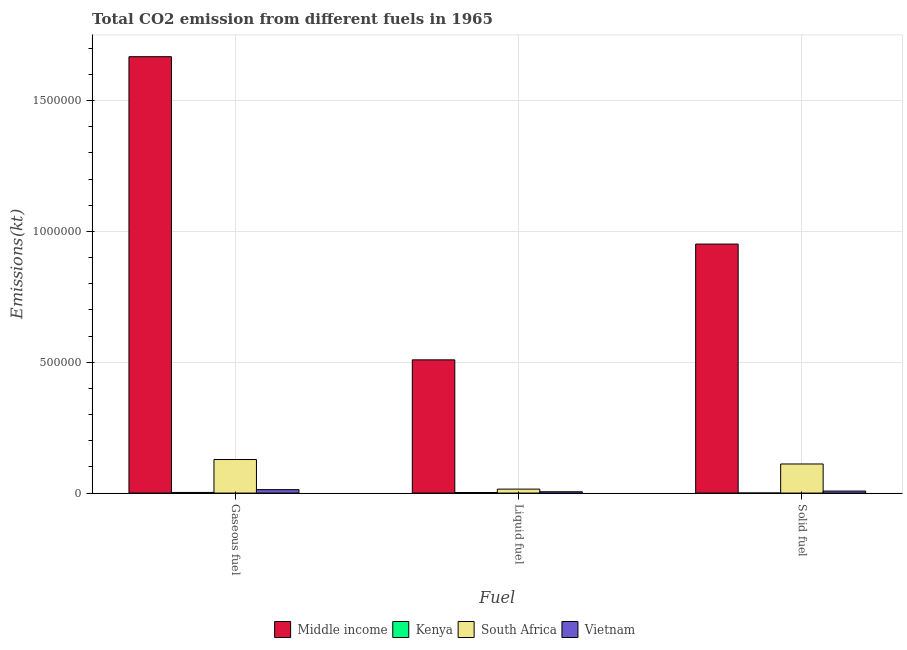How many different coloured bars are there?
Provide a succinct answer. 4. How many groups of bars are there?
Your response must be concise. 3. How many bars are there on the 2nd tick from the left?
Your answer should be compact. 4. How many bars are there on the 3rd tick from the right?
Provide a short and direct response. 4. What is the label of the 2nd group of bars from the left?
Your answer should be compact. Liquid fuel. What is the amount of co2 emissions from gaseous fuel in Middle income?
Provide a short and direct response. 1.67e+06. Across all countries, what is the maximum amount of co2 emissions from gaseous fuel?
Your answer should be very brief. 1.67e+06. Across all countries, what is the minimum amount of co2 emissions from solid fuel?
Ensure brevity in your answer.  146.68. In which country was the amount of co2 emissions from gaseous fuel minimum?
Your answer should be very brief. Kenya. What is the total amount of co2 emissions from gaseous fuel in the graph?
Give a very brief answer. 1.81e+06. What is the difference between the amount of co2 emissions from solid fuel in South Africa and that in Kenya?
Make the answer very short. 1.11e+05. What is the difference between the amount of co2 emissions from gaseous fuel in South Africa and the amount of co2 emissions from solid fuel in Kenya?
Provide a succinct answer. 1.28e+05. What is the average amount of co2 emissions from solid fuel per country?
Ensure brevity in your answer.  2.68e+05. What is the difference between the amount of co2 emissions from gaseous fuel and amount of co2 emissions from solid fuel in Kenya?
Offer a very short reply. 2321.21. What is the ratio of the amount of co2 emissions from liquid fuel in South Africa to that in Kenya?
Ensure brevity in your answer.  7.27. What is the difference between the highest and the second highest amount of co2 emissions from gaseous fuel?
Your response must be concise. 1.54e+06. What is the difference between the highest and the lowest amount of co2 emissions from solid fuel?
Provide a succinct answer. 9.52e+05. In how many countries, is the amount of co2 emissions from gaseous fuel greater than the average amount of co2 emissions from gaseous fuel taken over all countries?
Keep it short and to the point. 1. Is the sum of the amount of co2 emissions from solid fuel in Vietnam and Middle income greater than the maximum amount of co2 emissions from gaseous fuel across all countries?
Provide a short and direct response. No. What does the 3rd bar from the left in Gaseous fuel represents?
Offer a terse response. South Africa. What does the 3rd bar from the right in Liquid fuel represents?
Provide a short and direct response. Kenya. Is it the case that in every country, the sum of the amount of co2 emissions from gaseous fuel and amount of co2 emissions from liquid fuel is greater than the amount of co2 emissions from solid fuel?
Give a very brief answer. Yes. How many bars are there?
Give a very brief answer. 12. How many countries are there in the graph?
Your answer should be very brief. 4. What is the difference between two consecutive major ticks on the Y-axis?
Provide a short and direct response. 5.00e+05. Does the graph contain any zero values?
Ensure brevity in your answer.  No. Does the graph contain grids?
Keep it short and to the point. Yes. Where does the legend appear in the graph?
Your response must be concise. Bottom center. How are the legend labels stacked?
Your answer should be very brief. Horizontal. What is the title of the graph?
Keep it short and to the point. Total CO2 emission from different fuels in 1965. Does "Heavily indebted poor countries" appear as one of the legend labels in the graph?
Make the answer very short. No. What is the label or title of the X-axis?
Provide a short and direct response. Fuel. What is the label or title of the Y-axis?
Your response must be concise. Emissions(kt). What is the Emissions(kt) in Middle income in Gaseous fuel?
Your answer should be very brief. 1.67e+06. What is the Emissions(kt) of Kenya in Gaseous fuel?
Your answer should be compact. 2467.89. What is the Emissions(kt) in South Africa in Gaseous fuel?
Provide a succinct answer. 1.28e+05. What is the Emissions(kt) of Vietnam in Gaseous fuel?
Make the answer very short. 1.32e+04. What is the Emissions(kt) of Middle income in Liquid fuel?
Your response must be concise. 5.09e+05. What is the Emissions(kt) of Kenya in Liquid fuel?
Make the answer very short. 2082.86. What is the Emissions(kt) of South Africa in Liquid fuel?
Offer a terse response. 1.51e+04. What is the Emissions(kt) of Vietnam in Liquid fuel?
Offer a very short reply. 4998.12. What is the Emissions(kt) of Middle income in Solid fuel?
Offer a terse response. 9.52e+05. What is the Emissions(kt) of Kenya in Solid fuel?
Give a very brief answer. 146.68. What is the Emissions(kt) in South Africa in Solid fuel?
Your answer should be very brief. 1.11e+05. What is the Emissions(kt) in Vietnam in Solid fuel?
Offer a terse response. 7693.37. Across all Fuel, what is the maximum Emissions(kt) in Middle income?
Ensure brevity in your answer.  1.67e+06. Across all Fuel, what is the maximum Emissions(kt) in Kenya?
Offer a terse response. 2467.89. Across all Fuel, what is the maximum Emissions(kt) in South Africa?
Your response must be concise. 1.28e+05. Across all Fuel, what is the maximum Emissions(kt) of Vietnam?
Keep it short and to the point. 1.32e+04. Across all Fuel, what is the minimum Emissions(kt) of Middle income?
Your answer should be compact. 5.09e+05. Across all Fuel, what is the minimum Emissions(kt) of Kenya?
Keep it short and to the point. 146.68. Across all Fuel, what is the minimum Emissions(kt) of South Africa?
Offer a very short reply. 1.51e+04. Across all Fuel, what is the minimum Emissions(kt) of Vietnam?
Give a very brief answer. 4998.12. What is the total Emissions(kt) in Middle income in the graph?
Provide a succinct answer. 3.13e+06. What is the total Emissions(kt) in Kenya in the graph?
Keep it short and to the point. 4697.43. What is the total Emissions(kt) of South Africa in the graph?
Ensure brevity in your answer.  2.55e+05. What is the total Emissions(kt) in Vietnam in the graph?
Give a very brief answer. 2.59e+04. What is the difference between the Emissions(kt) of Middle income in Gaseous fuel and that in Liquid fuel?
Ensure brevity in your answer.  1.16e+06. What is the difference between the Emissions(kt) of Kenya in Gaseous fuel and that in Liquid fuel?
Your answer should be compact. 385.04. What is the difference between the Emissions(kt) in South Africa in Gaseous fuel and that in Liquid fuel?
Make the answer very short. 1.13e+05. What is the difference between the Emissions(kt) of Vietnam in Gaseous fuel and that in Liquid fuel?
Your response must be concise. 8166.41. What is the difference between the Emissions(kt) of Middle income in Gaseous fuel and that in Solid fuel?
Ensure brevity in your answer.  7.16e+05. What is the difference between the Emissions(kt) in Kenya in Gaseous fuel and that in Solid fuel?
Give a very brief answer. 2321.21. What is the difference between the Emissions(kt) in South Africa in Gaseous fuel and that in Solid fuel?
Ensure brevity in your answer.  1.71e+04. What is the difference between the Emissions(kt) of Vietnam in Gaseous fuel and that in Solid fuel?
Your answer should be compact. 5471.16. What is the difference between the Emissions(kt) in Middle income in Liquid fuel and that in Solid fuel?
Make the answer very short. -4.43e+05. What is the difference between the Emissions(kt) of Kenya in Liquid fuel and that in Solid fuel?
Provide a succinct answer. 1936.18. What is the difference between the Emissions(kt) of South Africa in Liquid fuel and that in Solid fuel?
Ensure brevity in your answer.  -9.61e+04. What is the difference between the Emissions(kt) in Vietnam in Liquid fuel and that in Solid fuel?
Your answer should be very brief. -2695.24. What is the difference between the Emissions(kt) in Middle income in Gaseous fuel and the Emissions(kt) in Kenya in Liquid fuel?
Ensure brevity in your answer.  1.67e+06. What is the difference between the Emissions(kt) of Middle income in Gaseous fuel and the Emissions(kt) of South Africa in Liquid fuel?
Keep it short and to the point. 1.65e+06. What is the difference between the Emissions(kt) of Middle income in Gaseous fuel and the Emissions(kt) of Vietnam in Liquid fuel?
Offer a terse response. 1.66e+06. What is the difference between the Emissions(kt) of Kenya in Gaseous fuel and the Emissions(kt) of South Africa in Liquid fuel?
Offer a very short reply. -1.27e+04. What is the difference between the Emissions(kt) of Kenya in Gaseous fuel and the Emissions(kt) of Vietnam in Liquid fuel?
Provide a succinct answer. -2530.23. What is the difference between the Emissions(kt) in South Africa in Gaseous fuel and the Emissions(kt) in Vietnam in Liquid fuel?
Offer a terse response. 1.23e+05. What is the difference between the Emissions(kt) in Middle income in Gaseous fuel and the Emissions(kt) in Kenya in Solid fuel?
Offer a terse response. 1.67e+06. What is the difference between the Emissions(kt) of Middle income in Gaseous fuel and the Emissions(kt) of South Africa in Solid fuel?
Give a very brief answer. 1.56e+06. What is the difference between the Emissions(kt) of Middle income in Gaseous fuel and the Emissions(kt) of Vietnam in Solid fuel?
Your response must be concise. 1.66e+06. What is the difference between the Emissions(kt) of Kenya in Gaseous fuel and the Emissions(kt) of South Africa in Solid fuel?
Offer a very short reply. -1.09e+05. What is the difference between the Emissions(kt) in Kenya in Gaseous fuel and the Emissions(kt) in Vietnam in Solid fuel?
Ensure brevity in your answer.  -5225.48. What is the difference between the Emissions(kt) in South Africa in Gaseous fuel and the Emissions(kt) in Vietnam in Solid fuel?
Your response must be concise. 1.21e+05. What is the difference between the Emissions(kt) of Middle income in Liquid fuel and the Emissions(kt) of Kenya in Solid fuel?
Ensure brevity in your answer.  5.09e+05. What is the difference between the Emissions(kt) in Middle income in Liquid fuel and the Emissions(kt) in South Africa in Solid fuel?
Make the answer very short. 3.98e+05. What is the difference between the Emissions(kt) of Middle income in Liquid fuel and the Emissions(kt) of Vietnam in Solid fuel?
Keep it short and to the point. 5.02e+05. What is the difference between the Emissions(kt) of Kenya in Liquid fuel and the Emissions(kt) of South Africa in Solid fuel?
Provide a short and direct response. -1.09e+05. What is the difference between the Emissions(kt) of Kenya in Liquid fuel and the Emissions(kt) of Vietnam in Solid fuel?
Keep it short and to the point. -5610.51. What is the difference between the Emissions(kt) in South Africa in Liquid fuel and the Emissions(kt) in Vietnam in Solid fuel?
Your answer should be compact. 7440.34. What is the average Emissions(kt) of Middle income per Fuel?
Ensure brevity in your answer.  1.04e+06. What is the average Emissions(kt) in Kenya per Fuel?
Your answer should be very brief. 1565.81. What is the average Emissions(kt) in South Africa per Fuel?
Your response must be concise. 8.49e+04. What is the average Emissions(kt) in Vietnam per Fuel?
Your answer should be compact. 8618.67. What is the difference between the Emissions(kt) of Middle income and Emissions(kt) of Kenya in Gaseous fuel?
Offer a terse response. 1.67e+06. What is the difference between the Emissions(kt) in Middle income and Emissions(kt) in South Africa in Gaseous fuel?
Offer a very short reply. 1.54e+06. What is the difference between the Emissions(kt) of Middle income and Emissions(kt) of Vietnam in Gaseous fuel?
Provide a short and direct response. 1.65e+06. What is the difference between the Emissions(kt) in Kenya and Emissions(kt) in South Africa in Gaseous fuel?
Provide a succinct answer. -1.26e+05. What is the difference between the Emissions(kt) of Kenya and Emissions(kt) of Vietnam in Gaseous fuel?
Offer a very short reply. -1.07e+04. What is the difference between the Emissions(kt) of South Africa and Emissions(kt) of Vietnam in Gaseous fuel?
Make the answer very short. 1.15e+05. What is the difference between the Emissions(kt) in Middle income and Emissions(kt) in Kenya in Liquid fuel?
Offer a very short reply. 5.07e+05. What is the difference between the Emissions(kt) in Middle income and Emissions(kt) in South Africa in Liquid fuel?
Offer a very short reply. 4.94e+05. What is the difference between the Emissions(kt) of Middle income and Emissions(kt) of Vietnam in Liquid fuel?
Your answer should be compact. 5.04e+05. What is the difference between the Emissions(kt) in Kenya and Emissions(kt) in South Africa in Liquid fuel?
Offer a very short reply. -1.31e+04. What is the difference between the Emissions(kt) in Kenya and Emissions(kt) in Vietnam in Liquid fuel?
Make the answer very short. -2915.26. What is the difference between the Emissions(kt) of South Africa and Emissions(kt) of Vietnam in Liquid fuel?
Make the answer very short. 1.01e+04. What is the difference between the Emissions(kt) of Middle income and Emissions(kt) of Kenya in Solid fuel?
Offer a very short reply. 9.52e+05. What is the difference between the Emissions(kt) in Middle income and Emissions(kt) in South Africa in Solid fuel?
Ensure brevity in your answer.  8.41e+05. What is the difference between the Emissions(kt) in Middle income and Emissions(kt) in Vietnam in Solid fuel?
Ensure brevity in your answer.  9.44e+05. What is the difference between the Emissions(kt) of Kenya and Emissions(kt) of South Africa in Solid fuel?
Offer a very short reply. -1.11e+05. What is the difference between the Emissions(kt) of Kenya and Emissions(kt) of Vietnam in Solid fuel?
Provide a succinct answer. -7546.69. What is the difference between the Emissions(kt) of South Africa and Emissions(kt) of Vietnam in Solid fuel?
Give a very brief answer. 1.03e+05. What is the ratio of the Emissions(kt) in Middle income in Gaseous fuel to that in Liquid fuel?
Give a very brief answer. 3.28. What is the ratio of the Emissions(kt) of Kenya in Gaseous fuel to that in Liquid fuel?
Ensure brevity in your answer.  1.18. What is the ratio of the Emissions(kt) in South Africa in Gaseous fuel to that in Liquid fuel?
Keep it short and to the point. 8.48. What is the ratio of the Emissions(kt) of Vietnam in Gaseous fuel to that in Liquid fuel?
Make the answer very short. 2.63. What is the ratio of the Emissions(kt) of Middle income in Gaseous fuel to that in Solid fuel?
Keep it short and to the point. 1.75. What is the ratio of the Emissions(kt) in Kenya in Gaseous fuel to that in Solid fuel?
Ensure brevity in your answer.  16.82. What is the ratio of the Emissions(kt) in South Africa in Gaseous fuel to that in Solid fuel?
Offer a terse response. 1.15. What is the ratio of the Emissions(kt) in Vietnam in Gaseous fuel to that in Solid fuel?
Your answer should be very brief. 1.71. What is the ratio of the Emissions(kt) of Middle income in Liquid fuel to that in Solid fuel?
Offer a terse response. 0.54. What is the ratio of the Emissions(kt) in Kenya in Liquid fuel to that in Solid fuel?
Keep it short and to the point. 14.2. What is the ratio of the Emissions(kt) of South Africa in Liquid fuel to that in Solid fuel?
Make the answer very short. 0.14. What is the ratio of the Emissions(kt) of Vietnam in Liquid fuel to that in Solid fuel?
Give a very brief answer. 0.65. What is the difference between the highest and the second highest Emissions(kt) of Middle income?
Give a very brief answer. 7.16e+05. What is the difference between the highest and the second highest Emissions(kt) of Kenya?
Provide a succinct answer. 385.04. What is the difference between the highest and the second highest Emissions(kt) in South Africa?
Your answer should be compact. 1.71e+04. What is the difference between the highest and the second highest Emissions(kt) in Vietnam?
Keep it short and to the point. 5471.16. What is the difference between the highest and the lowest Emissions(kt) of Middle income?
Keep it short and to the point. 1.16e+06. What is the difference between the highest and the lowest Emissions(kt) of Kenya?
Offer a terse response. 2321.21. What is the difference between the highest and the lowest Emissions(kt) in South Africa?
Your answer should be compact. 1.13e+05. What is the difference between the highest and the lowest Emissions(kt) of Vietnam?
Your response must be concise. 8166.41. 